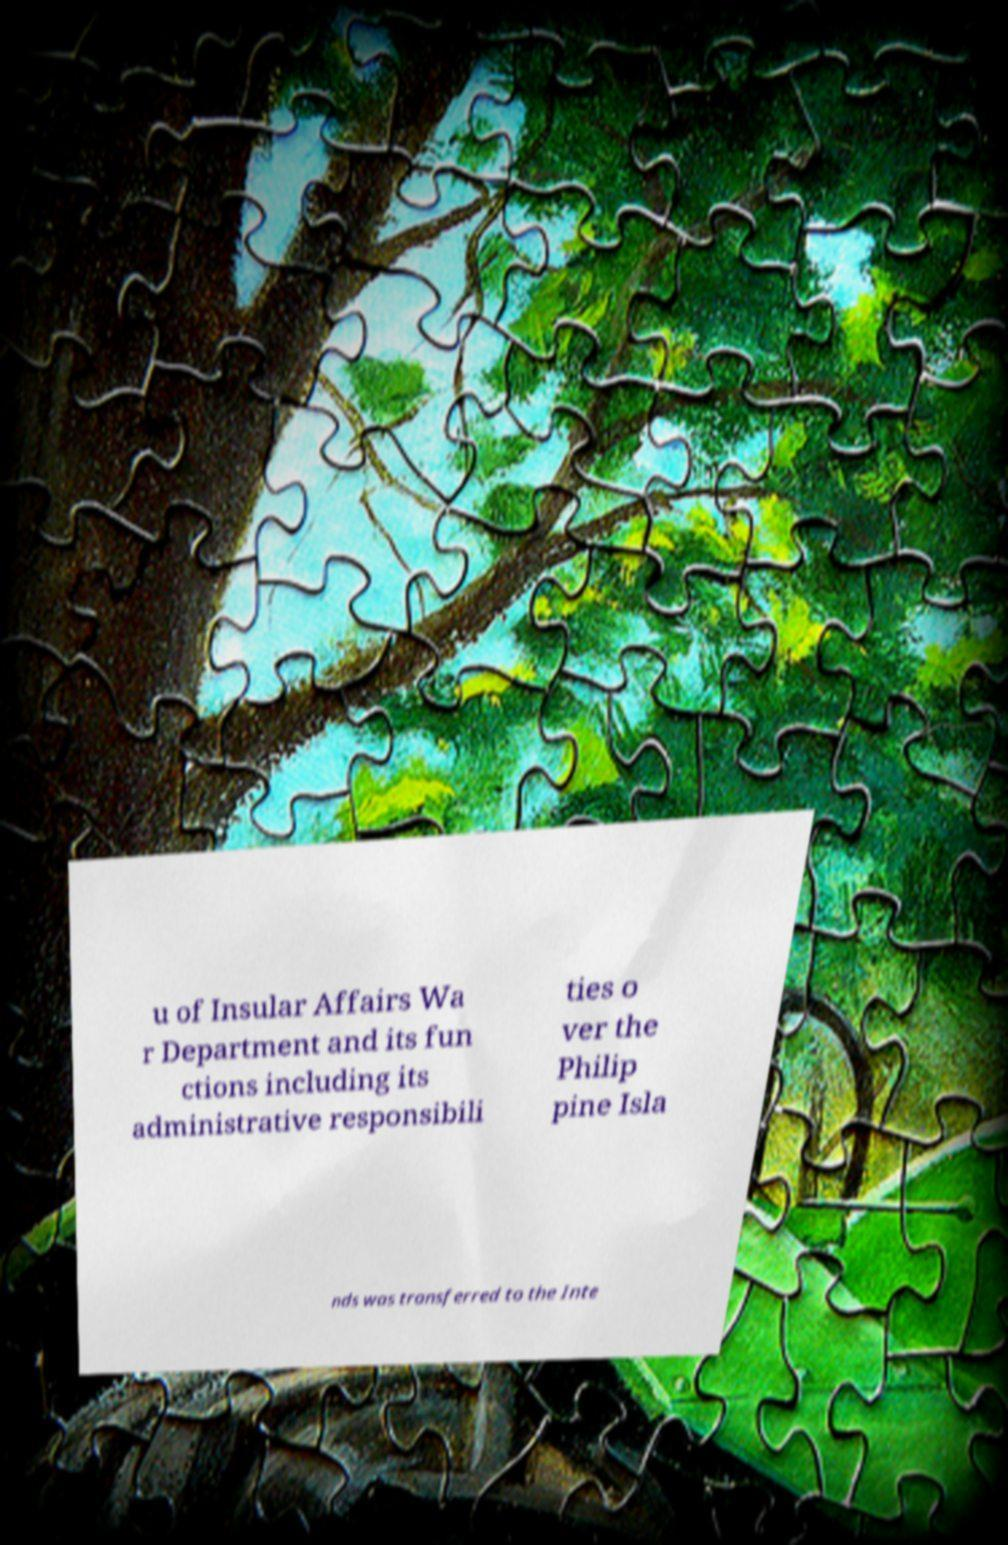Could you assist in decoding the text presented in this image and type it out clearly? u of Insular Affairs Wa r Department and its fun ctions including its administrative responsibili ties o ver the Philip pine Isla nds was transferred to the Inte 